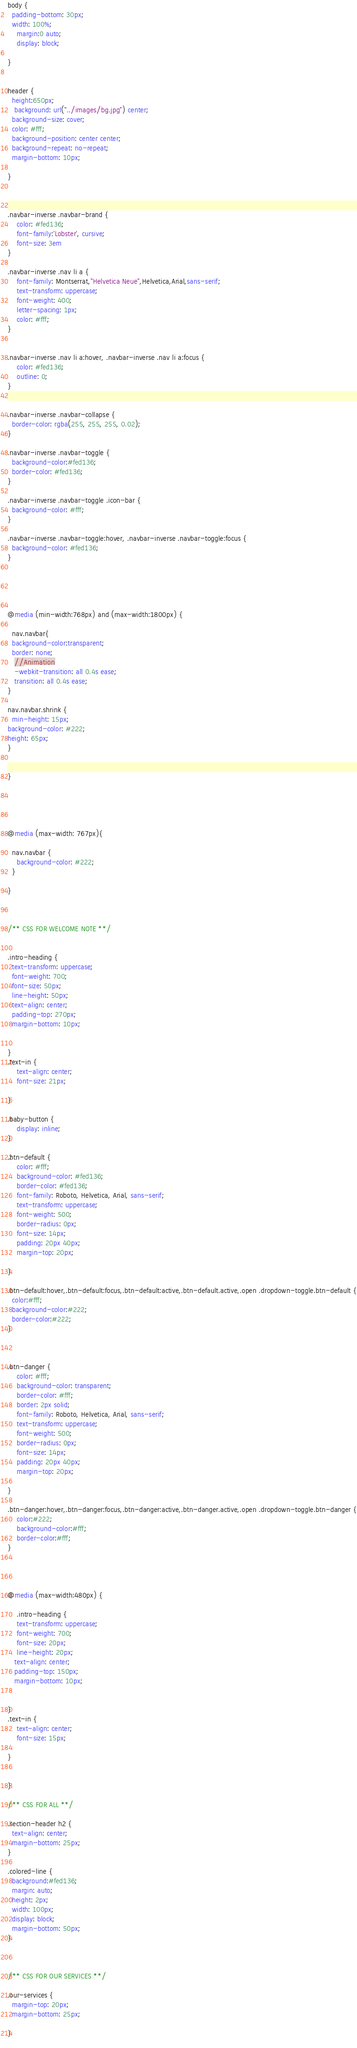Convert code to text. <code><loc_0><loc_0><loc_500><loc_500><_CSS_>body {
  padding-bottom: 30px;
  width: 100%;
    margin:0 auto;
    display: block;

}  

 
header {
  height:650px;
   background: url("../images/bg.jpg") center;
  background-size: cover;
  color: #fff;
  background-position: center center;
  background-repeat: no-repeat;
  margin-bottom: 10px;

}



.navbar-inverse .navbar-brand {
    color: #fed136;
    font-family:'Lobster', cursive;
    font-size: 3em
}

.navbar-inverse .nav li a {
    font-family: Montserrat,"Helvetica Neue",Helvetica,Arial,sans-serif;
    text-transform: uppercase;
    font-weight: 400;
    letter-spacing: 1px;
    color: #fff;
}


.navbar-inverse .nav li a:hover, .navbar-inverse .nav li a:focus {
    color: #fed136;
    outline: 0;
}


.navbar-inverse .navbar-collapse {
  border-color: rgba(255, 255, 255, 0.02);
}

.navbar-inverse .navbar-toggle {
  background-color:#fed136;
  border-color: #fed136;
}

.navbar-inverse .navbar-toggle .icon-bar {
  background-color: #fff;
}

.navbar-inverse .navbar-toggle:hover, .navbar-inverse .navbar-toggle:focus {
  background-color: #fed136;
}





@media (min-width:768px) and (max-width:1800px) {

  nav.navbar{
  background-color:transparent;
  border: none;
   //Animation
   -webkit-transition: all 0.4s ease;
   transition: all 0.4s ease;
}

nav.navbar.shrink {
  min-height: 15px;
background-color: #222;
height: 65px;
}


}
 




@media (max-width: 767px){

  nav.navbar {
    background-color: #222;
  }

}



/** CSS FOR WELCOME NOTE **/


.intro-heading {
  text-transform: uppercase;
  font-weight: 700;
  font-size: 50px;
  line-height: 50px;
  text-align: center;
  padding-top: 270px;
  margin-bottom: 10px;
      
    
}
.text-in {
    text-align: center;
    font-size: 21px;

}

.baby-button {
    display: inline;
}

.btn-default {
    color: #fff;
    background-color: #fed136;
    border-color: #fed136;
    font-family: Roboto, Helvetica, Arial, sans-serif;
    text-transform: uppercase;
    font-weight: 500;
    border-radius: 0px;
    font-size: 14px;
    padding: 20px 40px;
    margin-top: 20px;

}

.btn-default:hover,.btn-default:focus,.btn-default:active,.btn-default.active,.open .dropdown-toggle.btn-default {
  color:#fff;
  background-color:#222;
  border-color:#222;
}



.btn-danger {
    color: #fff;
    background-color: transparent;
    border-color: #fff;
    border: 2px solid;
    font-family: Roboto, Helvetica, Arial, sans-serif;
    text-transform: uppercase;
    font-weight: 500;
    border-radius: 0px;
    font-size: 14px;
    padding: 20px 40px;
    margin-top: 20px;

}

.btn-danger:hover,.btn-danger:focus,.btn-danger:active,.btn-danger.active,.open .dropdown-toggle.btn-danger {
    color:#222;
    background-color:#fff;
    border-color:#fff;
}




@media (max-width:480px) {

    .intro-heading {
    text-transform: uppercase;
    font-weight: 700;
    font-size: 20px;
    line-height: 20px;
   text-align: center;
   padding-top: 150px;
   margin-bottom: 10px;
      
    
}
.text-in {
    text-align: center;
    font-size: 15px;

}


}

/** CSS FOR ALL **/

.section-header h2 {
  text-align: center;
  margin-bottom: 25px;
}

.colored-line {
  background:#fed136;
  margin: auto;
  height: 2px;
  width: 100px;
  display: block;
  margin-bottom: 50px;
}



/** CSS FOR OUR SERVICES **/

.our-services {
  margin-top: 20px;
  margin-bottom: 25px;

}
 










</code> 